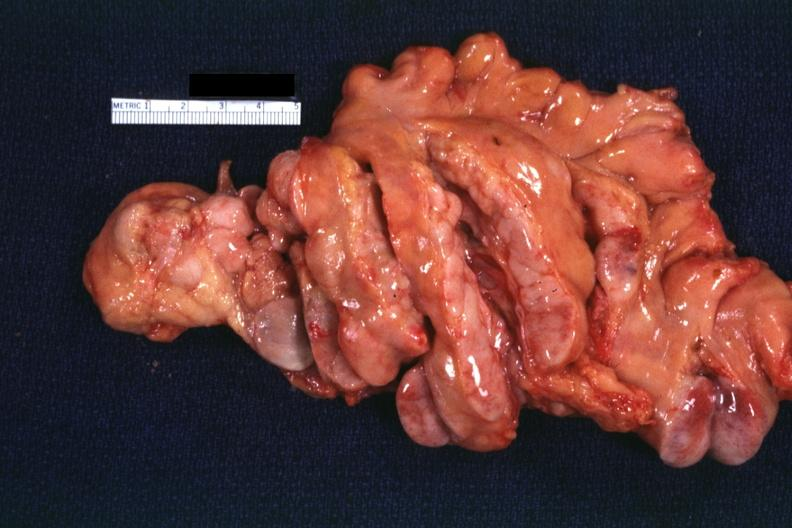what does this image show?
Answer the question using a single word or phrase. Rather good view of mesentery with typical large nodes case which may have been a t-cell lymphoma 